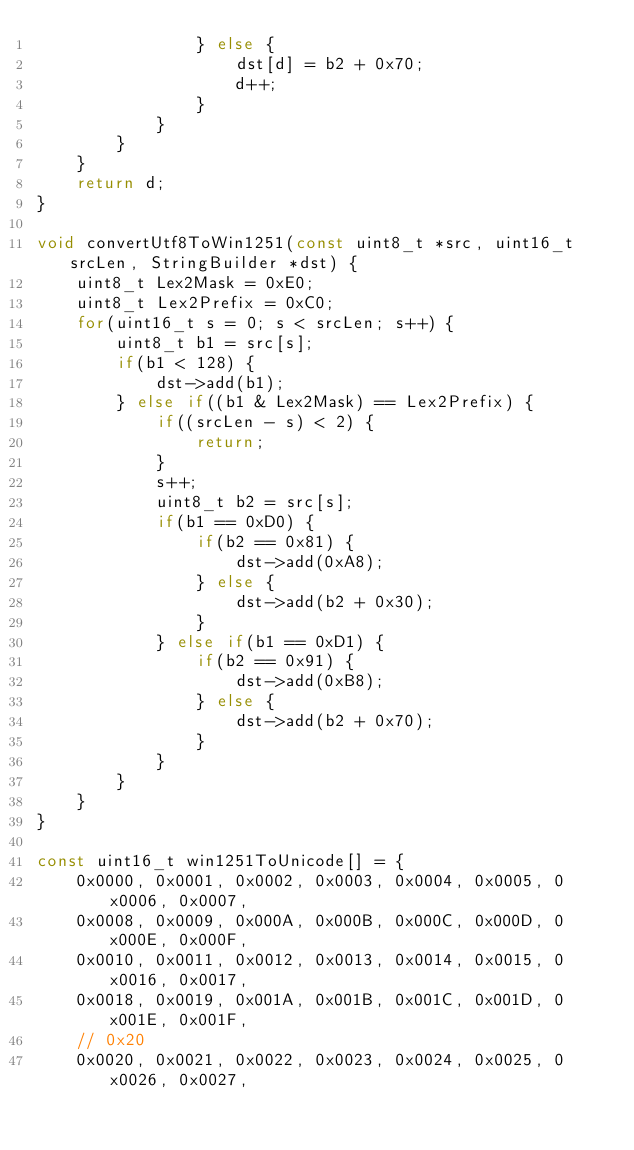Convert code to text. <code><loc_0><loc_0><loc_500><loc_500><_C++_>				} else {
					dst[d] = b2 + 0x70;
					d++;
				}
			}
		}
	}
	return d;
}

void convertUtf8ToWin1251(const uint8_t *src, uint16_t srcLen, StringBuilder *dst) {
	uint8_t Lex2Mask = 0xE0;
	uint8_t Lex2Prefix = 0xC0;
	for(uint16_t s = 0; s < srcLen; s++) {
		uint8_t b1 = src[s];
		if(b1 < 128) {
			dst->add(b1);
		} else if((b1 & Lex2Mask) == Lex2Prefix) {
			if((srcLen - s) < 2) {
				return;
			}
			s++;
			uint8_t b2 = src[s];
			if(b1 == 0xD0) {
				if(b2 == 0x81) {
					dst->add(0xA8);
				} else {
					dst->add(b2 + 0x30);
				}
			} else if(b1 == 0xD1) {
				if(b2 == 0x91) {
					dst->add(0xB8);
				} else {
					dst->add(b2 + 0x70);
				}
			}
		}
	}
}

const uint16_t win1251ToUnicode[] = {
	0x0000, 0x0001, 0x0002, 0x0003, 0x0004, 0x0005, 0x0006, 0x0007,
	0x0008, 0x0009, 0x000A, 0x000B, 0x000C, 0x000D, 0x000E, 0x000F,
	0x0010, 0x0011, 0x0012, 0x0013, 0x0014, 0x0015, 0x0016, 0x0017,
	0x0018, 0x0019, 0x001A, 0x001B, 0x001C, 0x001D, 0x001E, 0x001F,
	// 0x20
	0x0020, 0x0021, 0x0022, 0x0023, 0x0024, 0x0025, 0x0026, 0x0027,</code> 